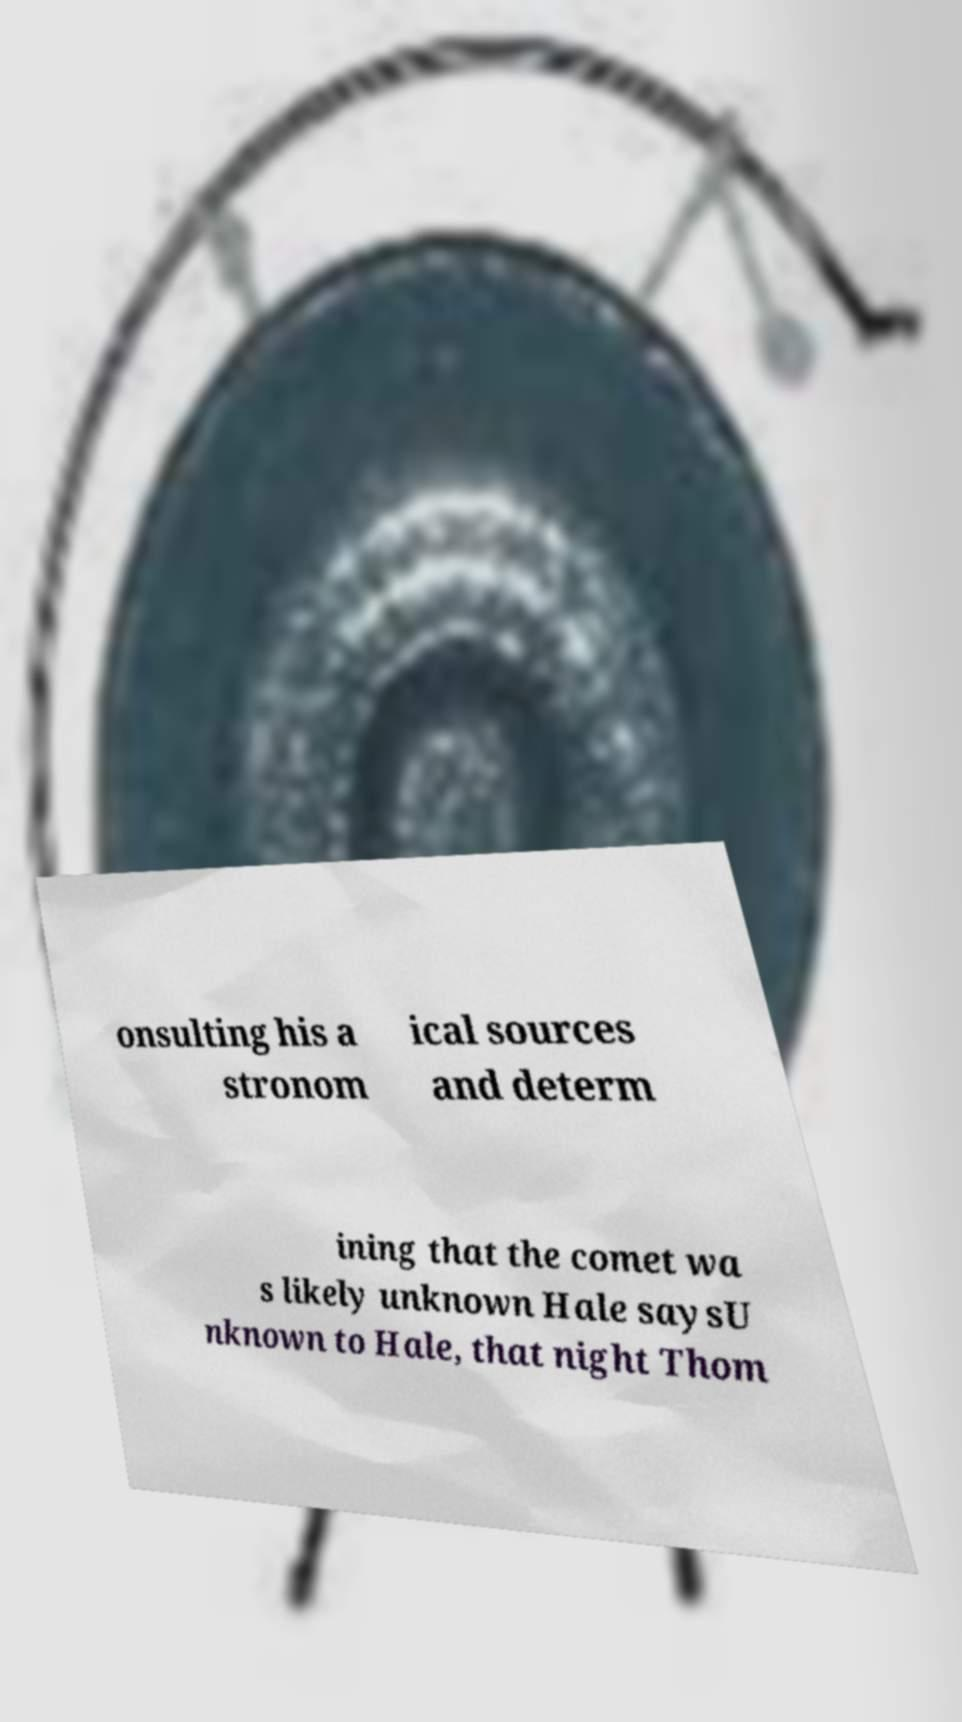There's text embedded in this image that I need extracted. Can you transcribe it verbatim? onsulting his a stronom ical sources and determ ining that the comet wa s likely unknown Hale saysU nknown to Hale, that night Thom 